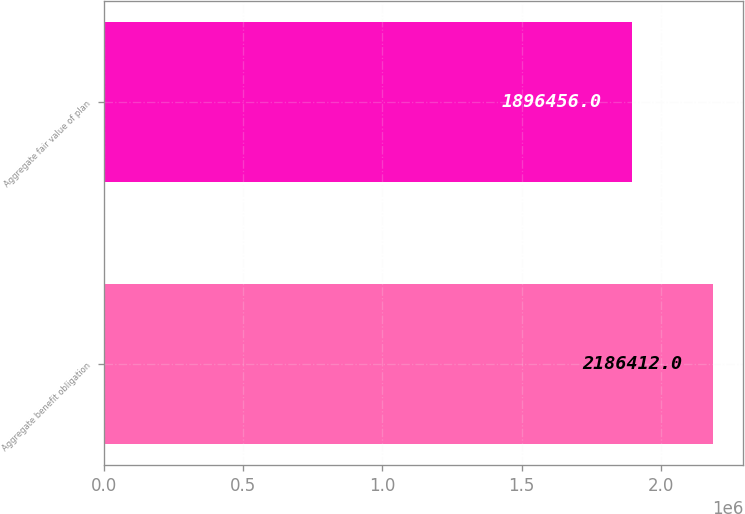<chart> <loc_0><loc_0><loc_500><loc_500><bar_chart><fcel>Aggregate benefit obligation<fcel>Aggregate fair value of plan<nl><fcel>2.18641e+06<fcel>1.89646e+06<nl></chart> 